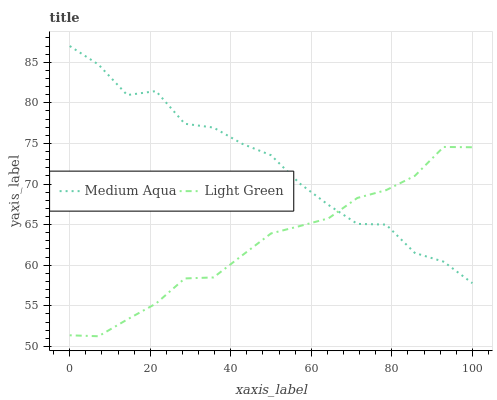Does Light Green have the minimum area under the curve?
Answer yes or no. Yes. Does Medium Aqua have the maximum area under the curve?
Answer yes or no. Yes. Does Light Green have the maximum area under the curve?
Answer yes or no. No. Is Light Green the smoothest?
Answer yes or no. Yes. Is Medium Aqua the roughest?
Answer yes or no. Yes. Is Light Green the roughest?
Answer yes or no. No. Does Light Green have the lowest value?
Answer yes or no. Yes. Does Medium Aqua have the highest value?
Answer yes or no. Yes. Does Light Green have the highest value?
Answer yes or no. No. Does Light Green intersect Medium Aqua?
Answer yes or no. Yes. Is Light Green less than Medium Aqua?
Answer yes or no. No. Is Light Green greater than Medium Aqua?
Answer yes or no. No. 